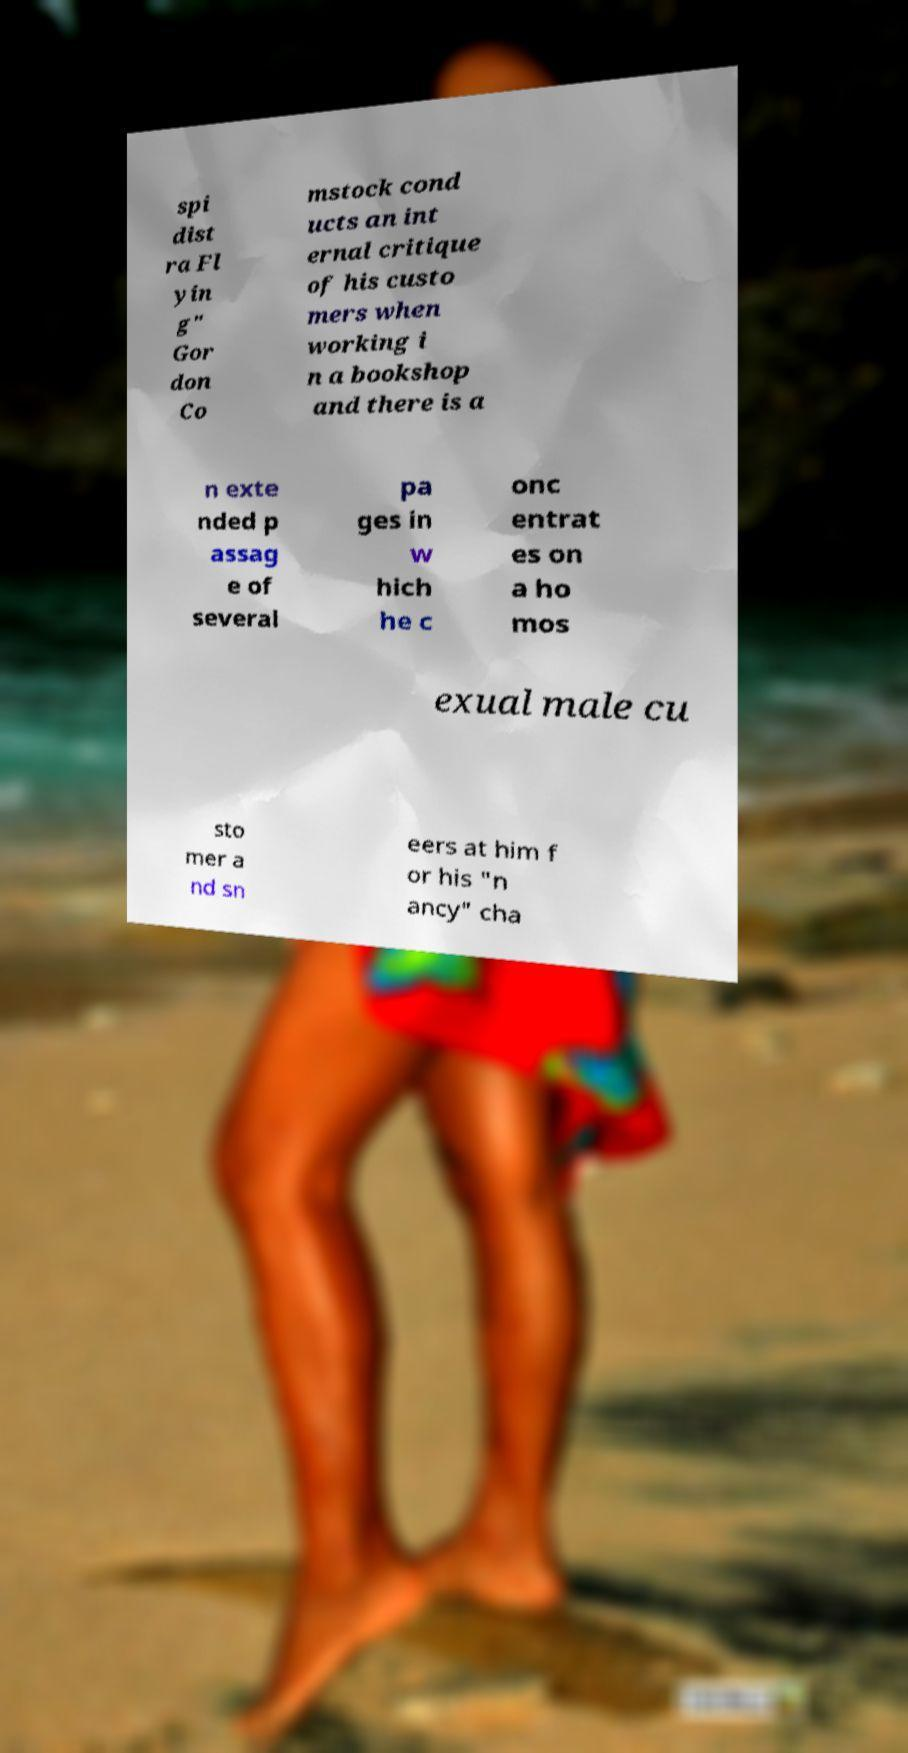Could you extract and type out the text from this image? spi dist ra Fl yin g" Gor don Co mstock cond ucts an int ernal critique of his custo mers when working i n a bookshop and there is a n exte nded p assag e of several pa ges in w hich he c onc entrat es on a ho mos exual male cu sto mer a nd sn eers at him f or his "n ancy" cha 